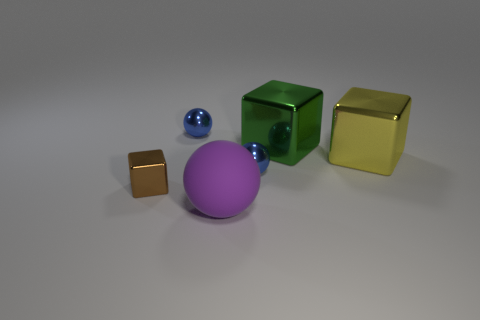Subtract all large green metallic blocks. How many blocks are left? 2 Subtract all cyan cylinders. How many blue balls are left? 2 Subtract 1 blocks. How many blocks are left? 2 Add 1 matte objects. How many objects exist? 7 Add 3 tiny gray metallic balls. How many tiny gray metallic balls exist? 3 Subtract 0 red blocks. How many objects are left? 6 Subtract all blue cylinders. Subtract all large things. How many objects are left? 3 Add 2 yellow blocks. How many yellow blocks are left? 3 